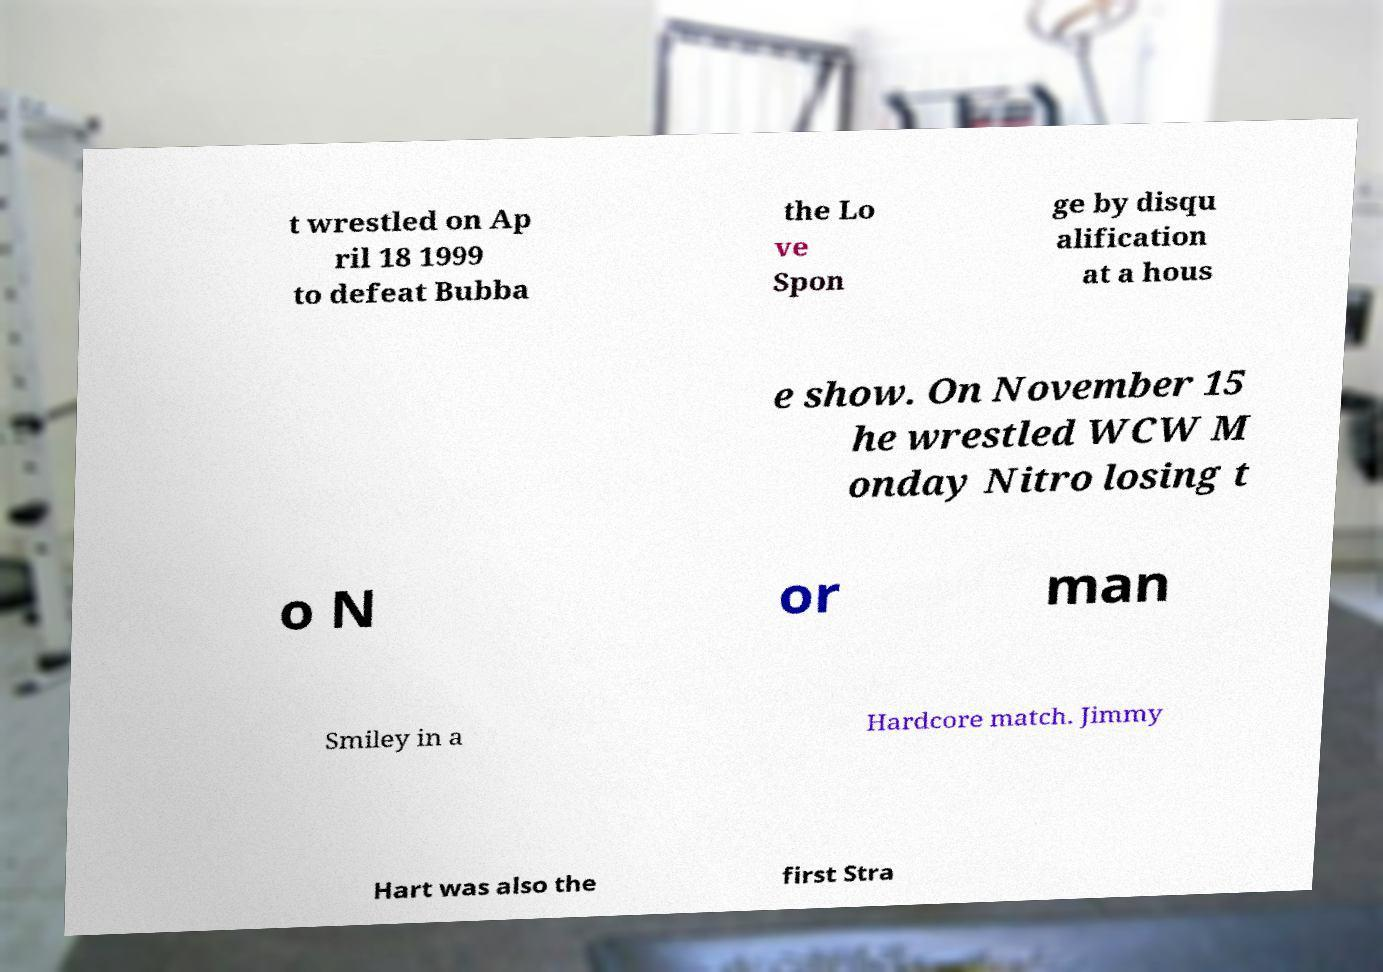For documentation purposes, I need the text within this image transcribed. Could you provide that? t wrestled on Ap ril 18 1999 to defeat Bubba the Lo ve Spon ge by disqu alification at a hous e show. On November 15 he wrestled WCW M onday Nitro losing t o N or man Smiley in a Hardcore match. Jimmy Hart was also the first Stra 